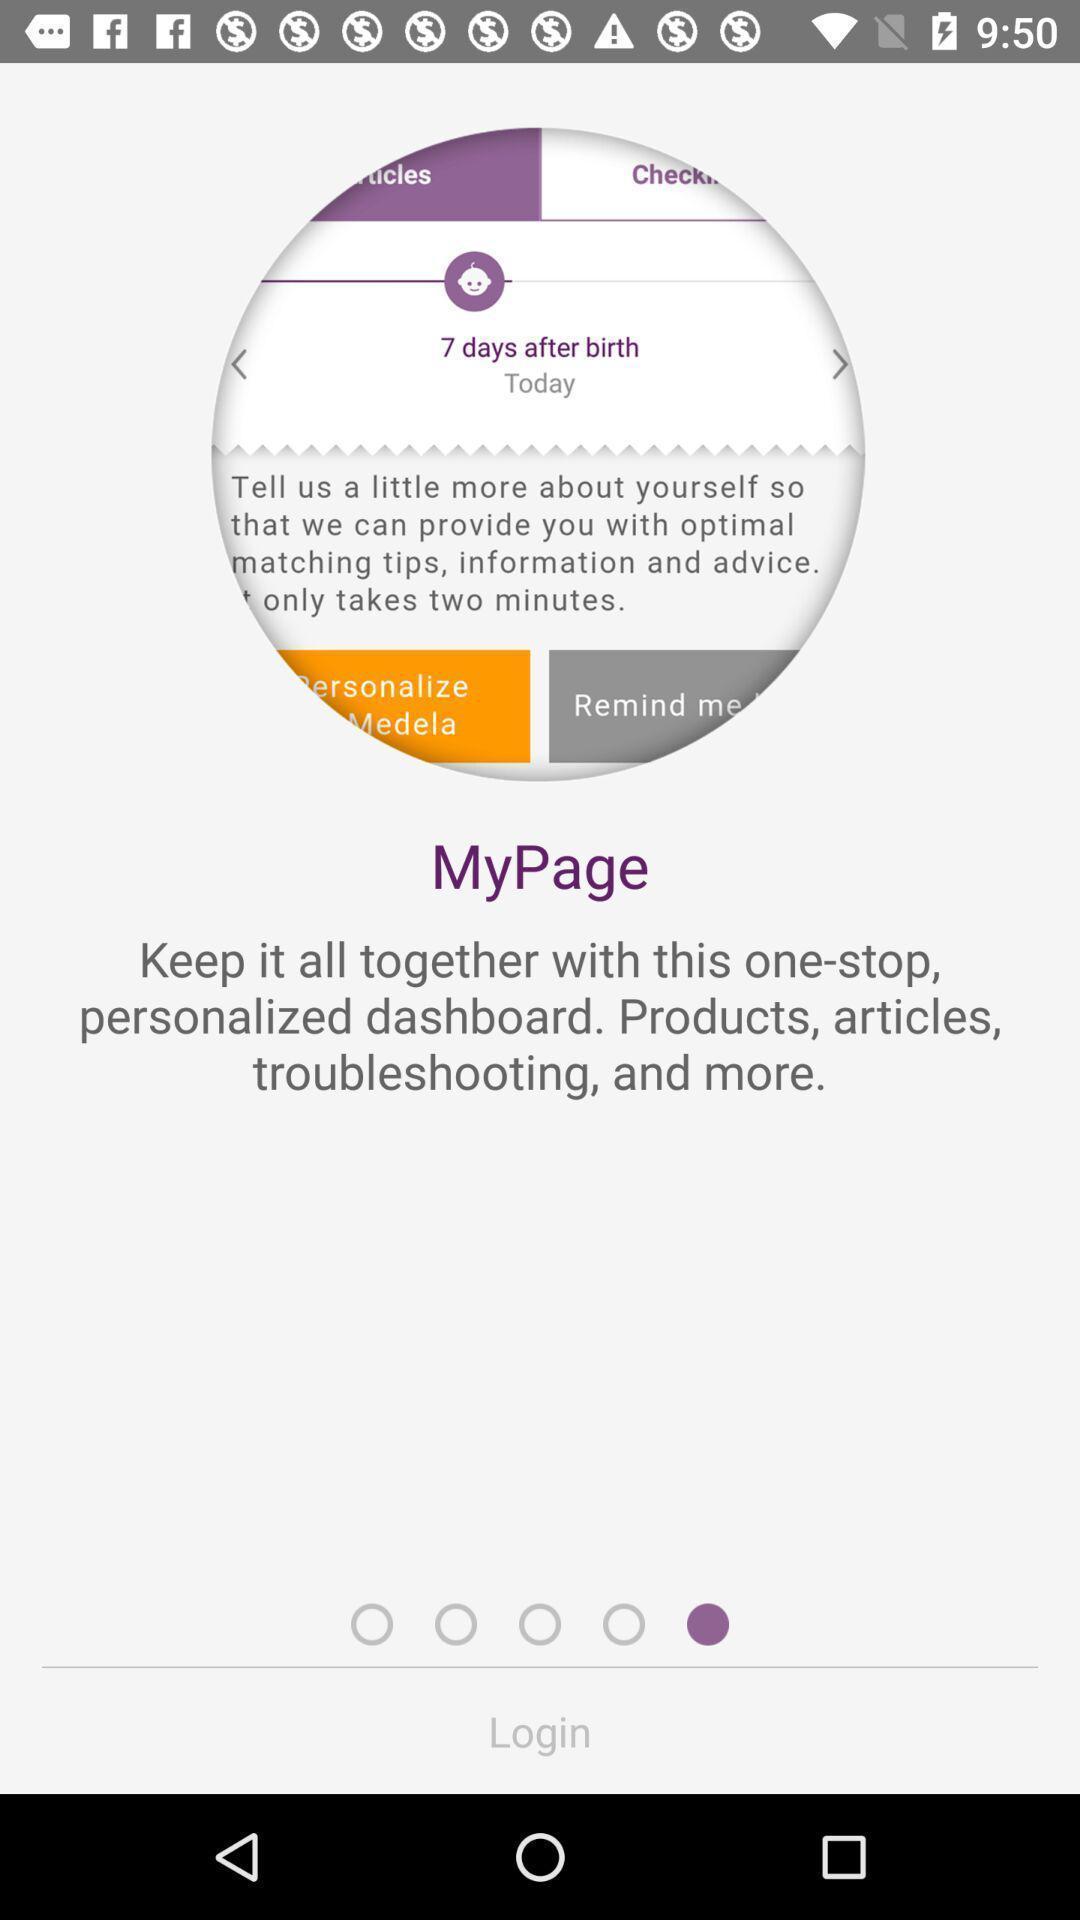Describe the visual elements of this screenshot. Welcome page of the social app for login. 